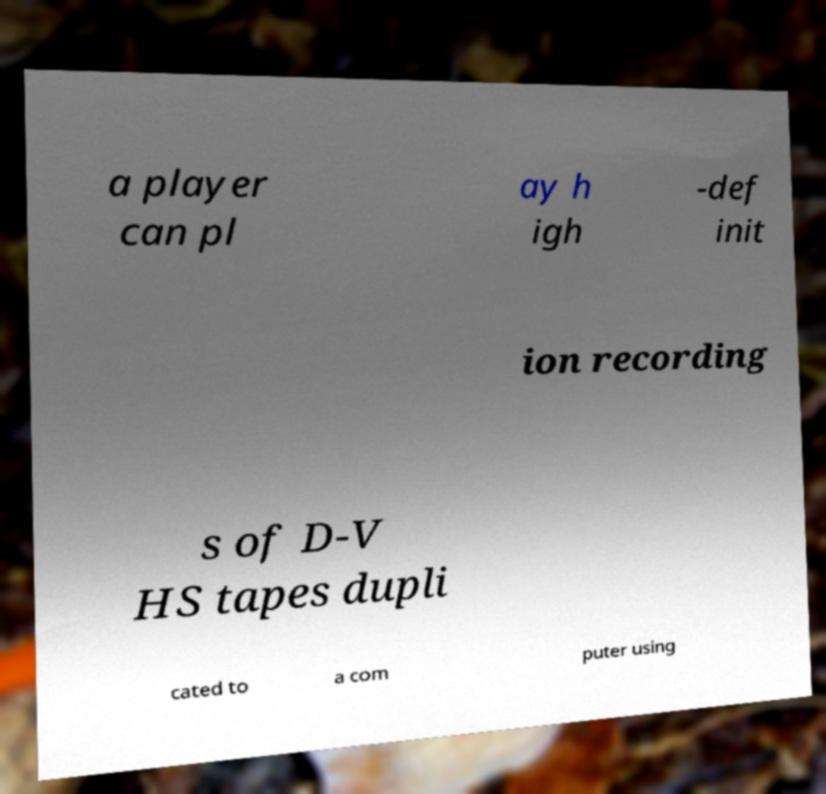There's text embedded in this image that I need extracted. Can you transcribe it verbatim? a player can pl ay h igh -def init ion recording s of D-V HS tapes dupli cated to a com puter using 